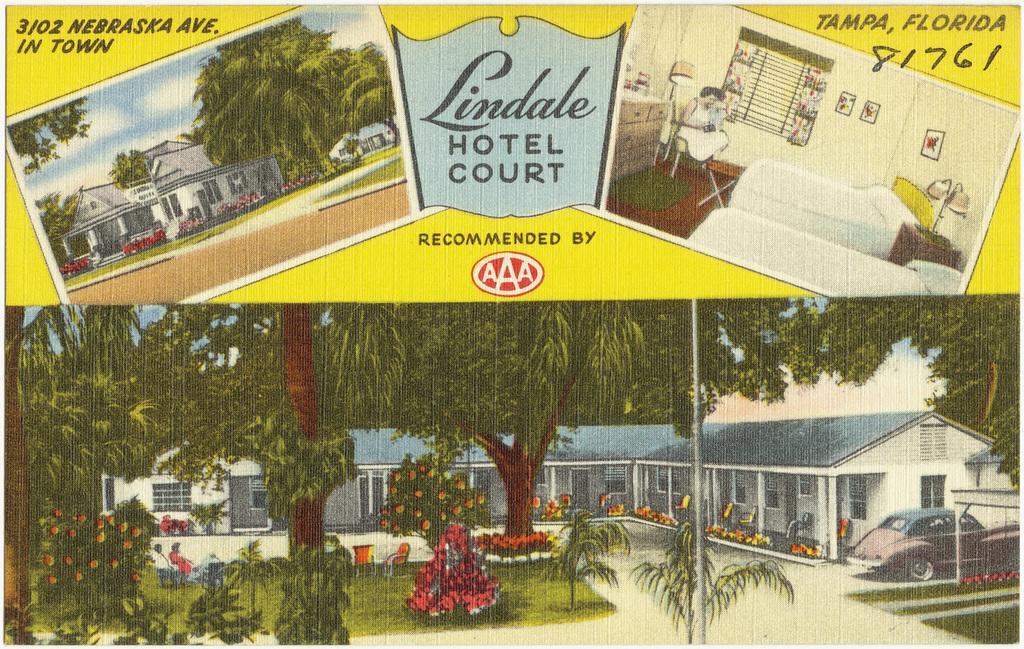In one or two sentences, can you explain what this image depicts? In this image, we can see a flyer contains depiction of trees, plants, roof houses, bed and some text. There is a car in the bottom right of the image. There is a pole at the bottom of the image. There is a person at the top of the image. 